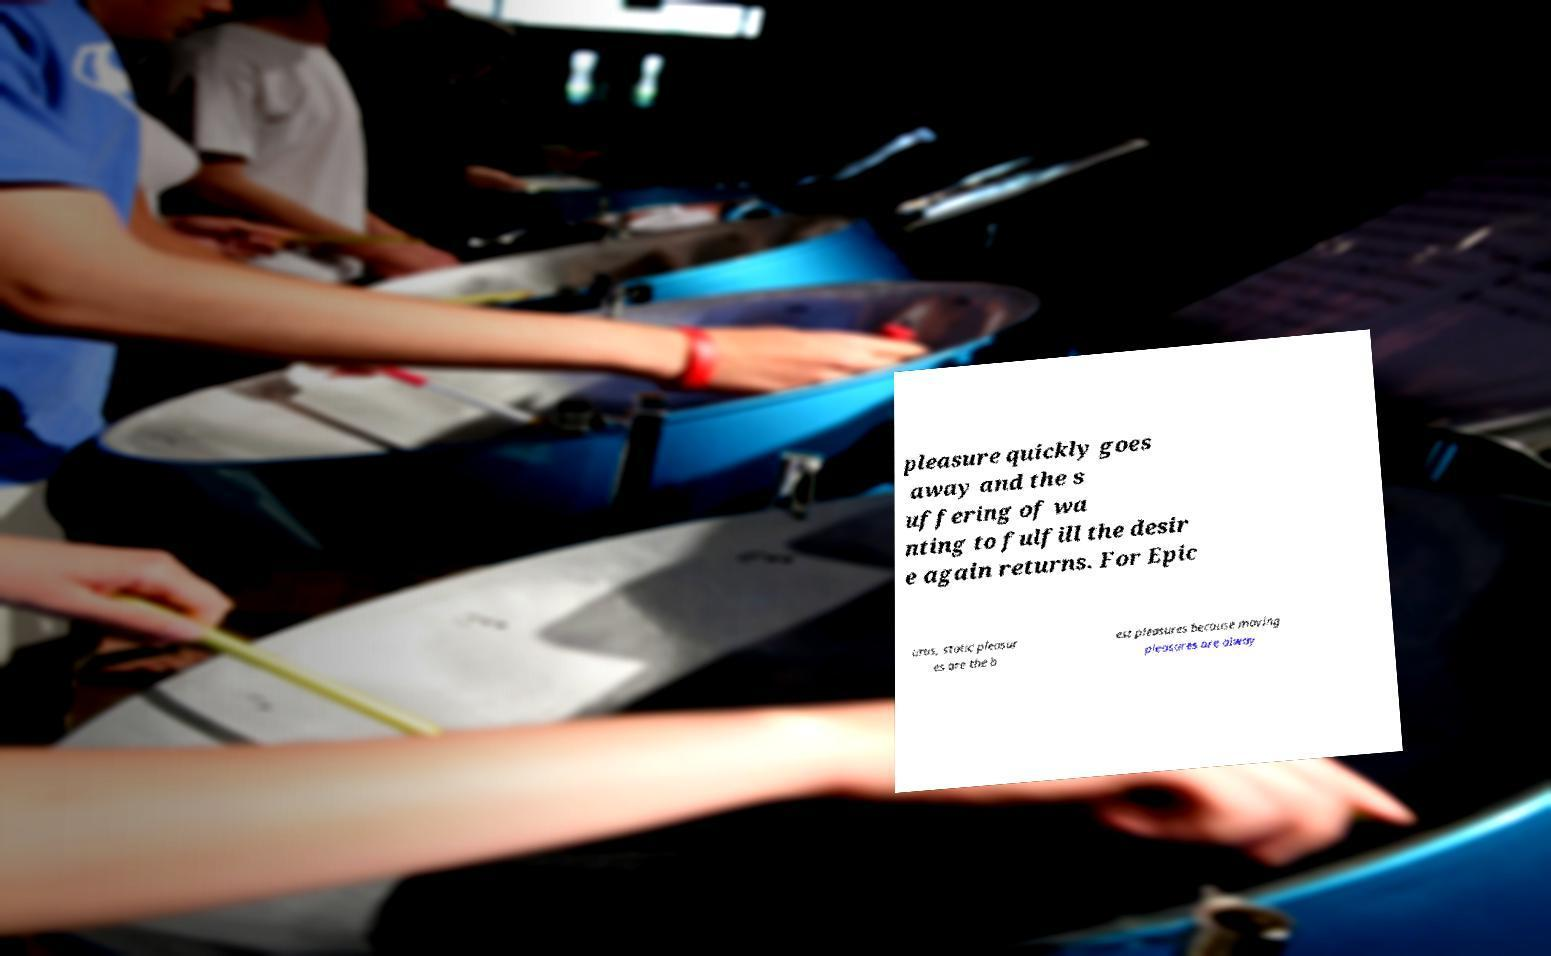Could you assist in decoding the text presented in this image and type it out clearly? pleasure quickly goes away and the s uffering of wa nting to fulfill the desir e again returns. For Epic urus, static pleasur es are the b est pleasures because moving pleasures are alway 